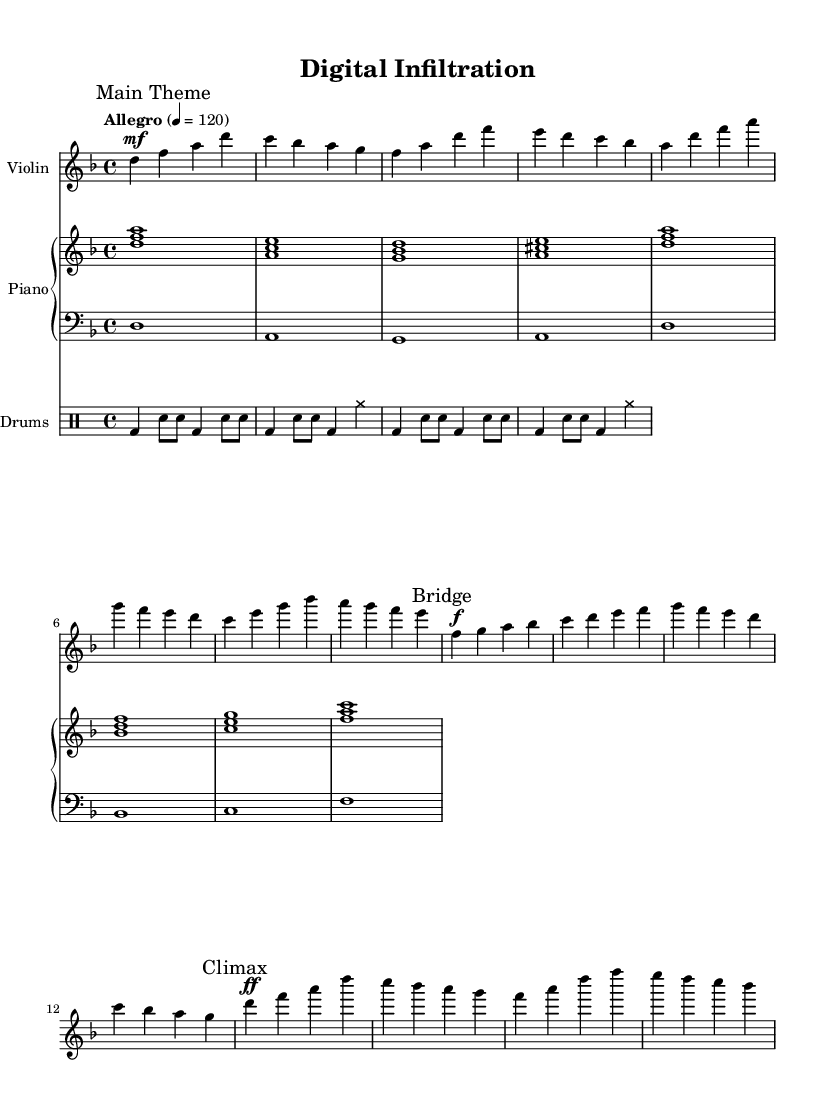What is the key signature of this music? The key signature is D minor, which has one flat (B flat).
Answer: D minor What is the time signature of this piece? The time signature is 4/4, indicating four beats per measure.
Answer: 4/4 What is the tempo marking for this score? The tempo marking is "Allegro" with a metronome marking of 120 beats per minute.
Answer: Allegro 4 = 120 Which instrument plays the main theme's melody? The violin plays the main theme's melody, as indicated in the score.
Answer: Violin How many measures are in the main theme section? The main theme consists of four measures based on the notation given.
Answer: Four measures What dynamic marking is indicated at the climax? The dynamic marking at the climax is ff, indicating a very loud intensity.
Answer: ff What type of film is this score tailored for? This score is tailored for a spy thriller movie, as it features orchestral elements typical of that genre.
Answer: Spy thriller 